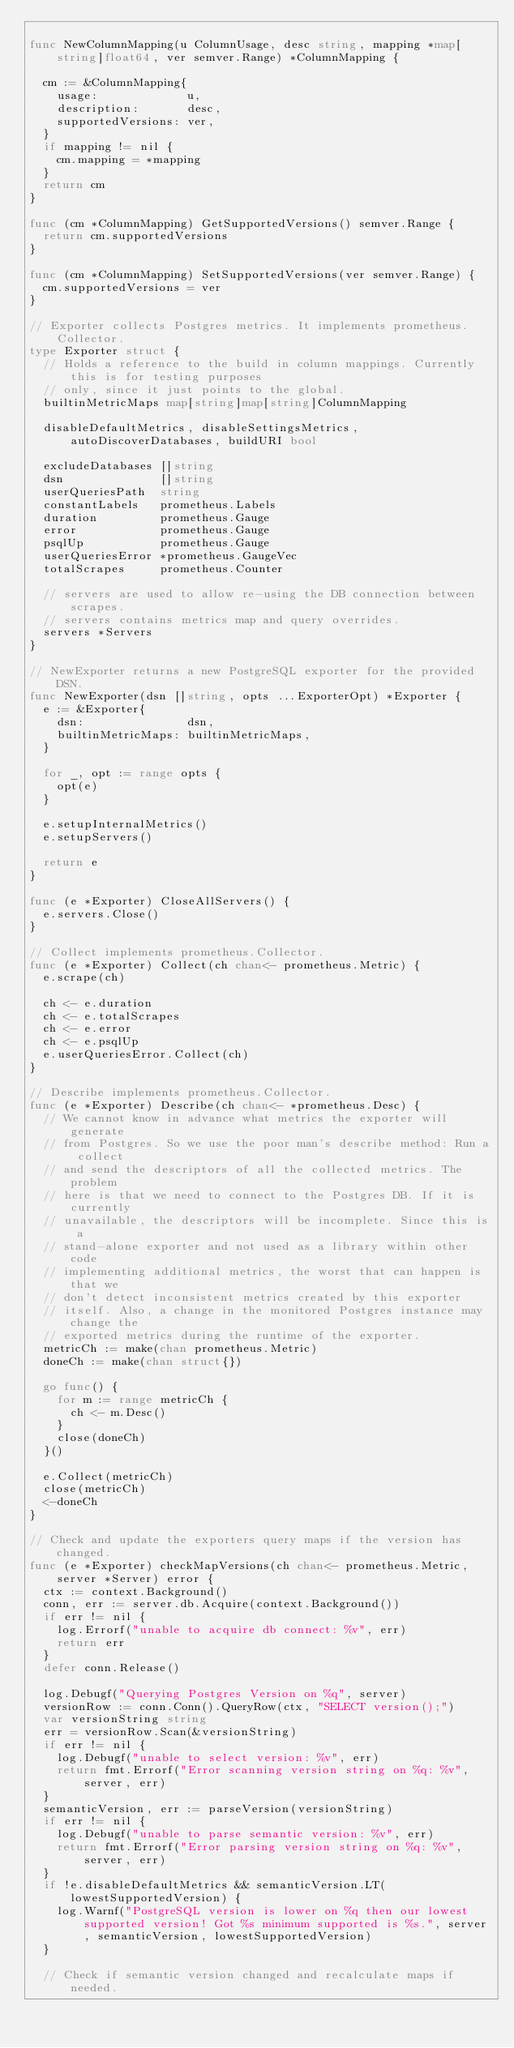<code> <loc_0><loc_0><loc_500><loc_500><_Go_>
func NewColumnMapping(u ColumnUsage, desc string, mapping *map[string]float64, ver semver.Range) *ColumnMapping {

	cm := &ColumnMapping{
		usage:             u,
		description:       desc,
		supportedVersions: ver,
	}
	if mapping != nil {
		cm.mapping = *mapping
	}
	return cm
}

func (cm *ColumnMapping) GetSupportedVersions() semver.Range {
	return cm.supportedVersions
}

func (cm *ColumnMapping) SetSupportedVersions(ver semver.Range) {
	cm.supportedVersions = ver
}

// Exporter collects Postgres metrics. It implements prometheus.Collector.
type Exporter struct {
	// Holds a reference to the build in column mappings. Currently this is for testing purposes
	// only, since it just points to the global.
	builtinMetricMaps map[string]map[string]ColumnMapping

	disableDefaultMetrics, disableSettingsMetrics, autoDiscoverDatabases, buildURI bool

	excludeDatabases []string
	dsn              []string
	userQueriesPath  string
	constantLabels   prometheus.Labels
	duration         prometheus.Gauge
	error            prometheus.Gauge
	psqlUp           prometheus.Gauge
	userQueriesError *prometheus.GaugeVec
	totalScrapes     prometheus.Counter

	// servers are used to allow re-using the DB connection between scrapes.
	// servers contains metrics map and query overrides.
	servers *Servers
}

// NewExporter returns a new PostgreSQL exporter for the provided DSN.
func NewExporter(dsn []string, opts ...ExporterOpt) *Exporter {
	e := &Exporter{
		dsn:               dsn,
		builtinMetricMaps: builtinMetricMaps,
	}

	for _, opt := range opts {
		opt(e)
	}

	e.setupInternalMetrics()
	e.setupServers()

	return e
}

func (e *Exporter) CloseAllServers() {
	e.servers.Close()
}

// Collect implements prometheus.Collector.
func (e *Exporter) Collect(ch chan<- prometheus.Metric) {
	e.scrape(ch)

	ch <- e.duration
	ch <- e.totalScrapes
	ch <- e.error
	ch <- e.psqlUp
	e.userQueriesError.Collect(ch)
}

// Describe implements prometheus.Collector.
func (e *Exporter) Describe(ch chan<- *prometheus.Desc) {
	// We cannot know in advance what metrics the exporter will generate
	// from Postgres. So we use the poor man's describe method: Run a collect
	// and send the descriptors of all the collected metrics. The problem
	// here is that we need to connect to the Postgres DB. If it is currently
	// unavailable, the descriptors will be incomplete. Since this is a
	// stand-alone exporter and not used as a library within other code
	// implementing additional metrics, the worst that can happen is that we
	// don't detect inconsistent metrics created by this exporter
	// itself. Also, a change in the monitored Postgres instance may change the
	// exported metrics during the runtime of the exporter.
	metricCh := make(chan prometheus.Metric)
	doneCh := make(chan struct{})

	go func() {
		for m := range metricCh {
			ch <- m.Desc()
		}
		close(doneCh)
	}()

	e.Collect(metricCh)
	close(metricCh)
	<-doneCh
}

// Check and update the exporters query maps if the version has changed.
func (e *Exporter) checkMapVersions(ch chan<- prometheus.Metric, server *Server) error {
	ctx := context.Background()
	conn, err := server.db.Acquire(context.Background())
	if err != nil {
		log.Errorf("unable to acquire db connect: %v", err)
		return err
	}
	defer conn.Release()

	log.Debugf("Querying Postgres Version on %q", server)
	versionRow := conn.Conn().QueryRow(ctx, "SELECT version();")
	var versionString string
	err = versionRow.Scan(&versionString)
	if err != nil {
		log.Debugf("unable to select version: %v", err)
		return fmt.Errorf("Error scanning version string on %q: %v", server, err)
	}
	semanticVersion, err := parseVersion(versionString)
	if err != nil {
		log.Debugf("unable to parse semantic version: %v", err)
		return fmt.Errorf("Error parsing version string on %q: %v", server, err)
	}
	if !e.disableDefaultMetrics && semanticVersion.LT(lowestSupportedVersion) {
		log.Warnf("PostgreSQL version is lower on %q then our lowest supported version! Got %s minimum supported is %s.", server, semanticVersion, lowestSupportedVersion)
	}

	// Check if semantic version changed and recalculate maps if needed.</code> 